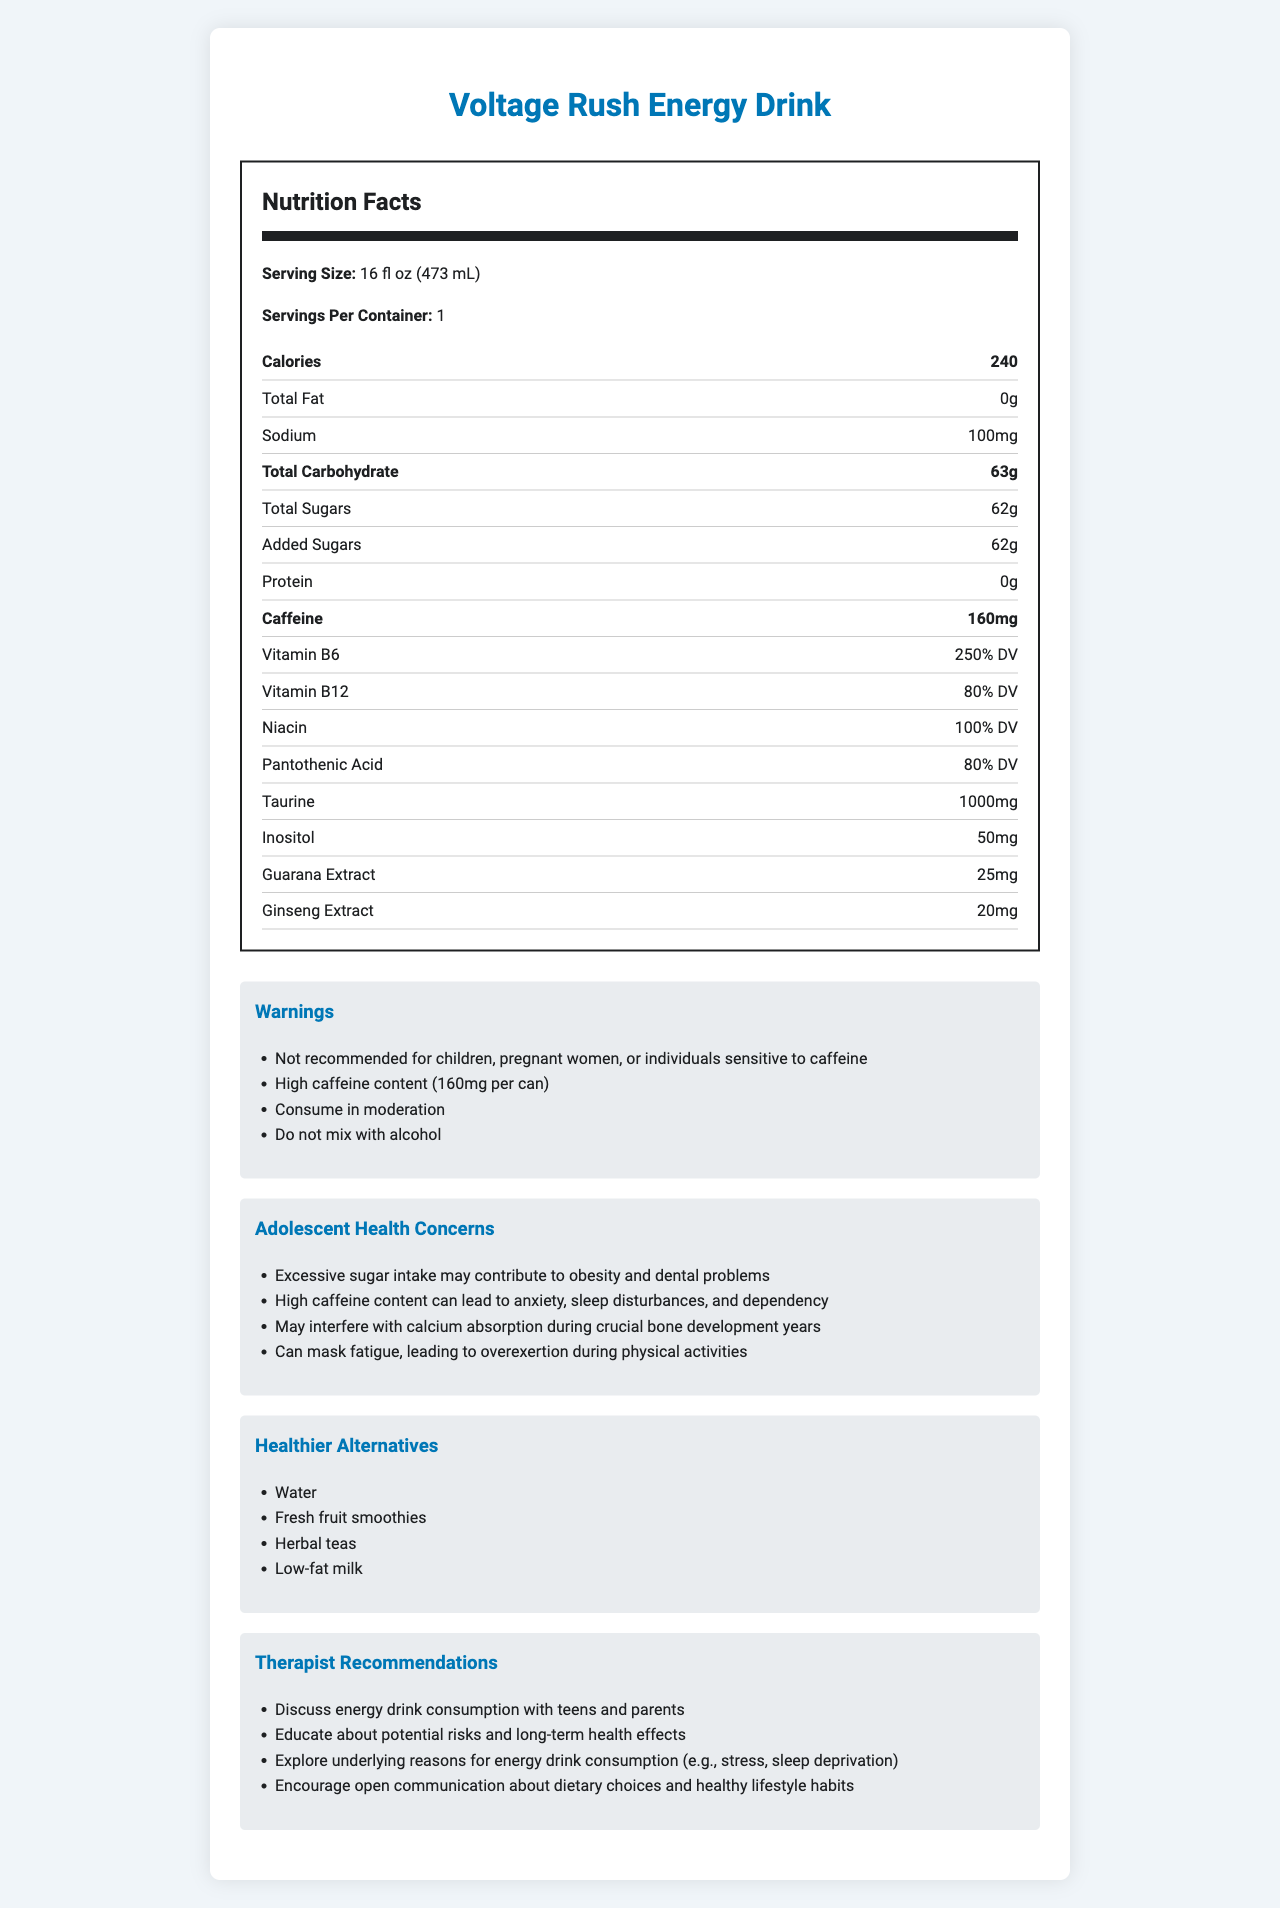what is the serving size of Voltage Rush Energy Drink? The serving size is clearly mentioned under the product name in the Nutrition Facts.
Answer: 16 fl oz (473 mL) how many calories are in one serving of Voltage Rush Energy Drink? The document states that the energy drink contains 240 calories per serving.
Answer: 240 how much caffeine does a single can of Voltage Rush Energy Drink contain? The caffeine content per can is listed as 160mg in the Nutrition Facts.
Answer: 160mg how many grams of total sugars are in one can of Voltage Rush Energy Drink? The total sugars amount is displayed under the Total Carbohydrate section as 62g.
Answer: 62g is there any protein in Voltage Rush Energy Drink? The protein content is listed as 0g in the Nutrition Facts.
Answer: No what are some concerns associated with the consumption of Voltage Rush Energy Drink by adolescents? These concerns are detailed under the section titled "Adolescent Health Concerns."
Answer: Excessive sugar intake may contribute to obesity and dental problems; High caffeine content can lead to anxiety, sleep disturbances, and dependency; May interfere with calcium absorption during crucial bone development years; Can mask fatigue, leading to overexertion during physical activities which vitamin has the highest daily value percentage in Voltage Rush Energy Drink? A. Vitamin B12 B. Niacin C. Vitamin B6 D. Pantothenic Acid Vitamin B6 has 250% DV, which is higher than the other listed vitamins, making it the highest.
Answer: C. Vitamin B6 what is one of the warnings associated with Voltage Rush Energy Drink? A. Consume before exercise B. High sugar content C. Do not mix with alcohol This warning is listed under the "Warnings" section.
Answer: C. Do not mix with alcohol can children safely consume Voltage Rush Energy Drink? The document explicitly states that the drink is "Not recommended for children."
Answer: No summarize the key points of the document. The document is a comprehensive overview of the nutritional aspects of the energy drink, including both its nutritional data and the associated risks and recommendations for healthier choices and discussions with adolescents.
Answer: The document provides detailed nutrition facts about Voltage Rush Energy Drink, highlighting it as a high-caffeine, high-sugar beverage. It lists caloric and nutritional contents, warnings, potential adolescent health concerns, healthier alternatives, and therapist recommendations. why is it important to discuss energy drink consumption with teens and parents? The document lists these reasons under the "Therapist Recommendations," emphasizing the importance of open communication and education on healthy lifestyle habits.
Answer: It helps educate about the potential risks and long-term health effects, and explore underlying reasons for consumption such as stress or sleep deprivation. what is the pantothenic acid content in Voltage Rush Energy Drink? The content of pantothenic acid is listed as 80% of the daily value in the Nutrition Facts section.
Answer: 80% DV how many servings are in one container of Voltage Rush Energy Drink? The Nutrition Facts state that there is 1 serving per container.
Answer: 1 which ingredient in Voltage Rush Energy Drink is present in the highest quantity excluding water and sugar? Among the listed ingredients and their quantities, taurine is present in the highest amount at 1000mg.
Answer: Taurine (1000mg) 